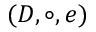Convert formula to latex. <formula><loc_0><loc_0><loc_500><loc_500>( D , \circ , e )</formula> 